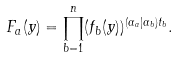Convert formula to latex. <formula><loc_0><loc_0><loc_500><loc_500>F _ { a } ( y ) = \prod _ { b = 1 } ^ { n } ( f _ { b } ( y ) ) ^ { ( \alpha _ { a } | \alpha _ { b } ) t _ { b } } .</formula> 